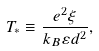<formula> <loc_0><loc_0><loc_500><loc_500>T _ { * } \equiv \frac { e ^ { 2 } \xi } { k _ { B } \varepsilon d ^ { 2 } } ,</formula> 